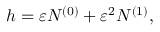Convert formula to latex. <formula><loc_0><loc_0><loc_500><loc_500>h = \varepsilon N ^ { ( 0 ) } + \varepsilon ^ { 2 } N ^ { ( 1 ) } ,</formula> 